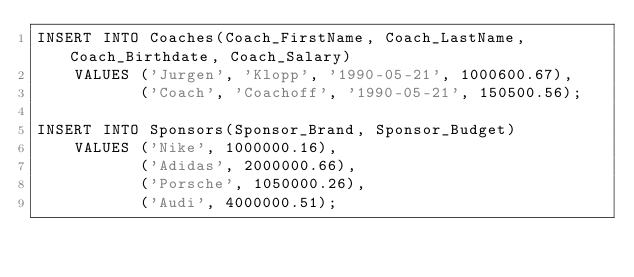Convert code to text. <code><loc_0><loc_0><loc_500><loc_500><_SQL_>INSERT INTO Coaches(Coach_FirstName, Coach_LastName, Coach_Birthdate, Coach_Salary)
	VALUES ('Jurgen', 'Klopp', '1990-05-21', 1000600.67),
		   ('Coach', 'Coachoff', '1990-05-21', 150500.56);

INSERT INTO Sponsors(Sponsor_Brand, Sponsor_Budget)
	VALUES ('Nike', 1000000.16),
	       ('Adidas', 2000000.66),
	       ('Porsche', 1050000.26),
	       ('Audi', 4000000.51);</code> 